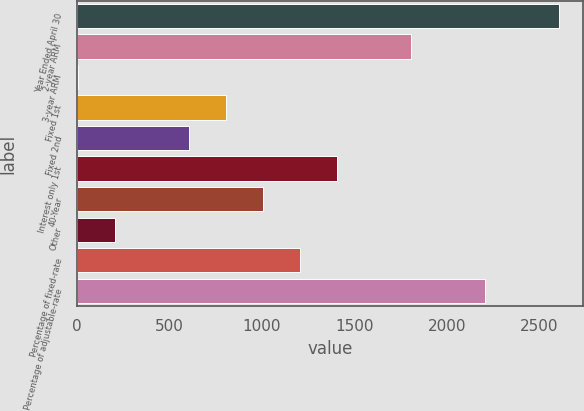<chart> <loc_0><loc_0><loc_500><loc_500><bar_chart><fcel>Year Ended April 30<fcel>2-year ARM<fcel>3-year ARM<fcel>Fixed 1st<fcel>Fixed 2nd<fcel>Interest only 1st<fcel>40-Year<fcel>Other<fcel>Percentage of fixed-rate<fcel>Percentage of adjustable-rate<nl><fcel>2607.23<fcel>1805.59<fcel>1.9<fcel>803.54<fcel>603.13<fcel>1404.77<fcel>1003.95<fcel>202.31<fcel>1204.36<fcel>2206.41<nl></chart> 